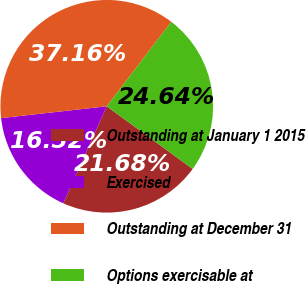<chart> <loc_0><loc_0><loc_500><loc_500><pie_chart><fcel>Outstanding at January 1 2015<fcel>Exercised<fcel>Outstanding at December 31<fcel>Options exercisable at<nl><fcel>21.68%<fcel>16.52%<fcel>37.16%<fcel>24.64%<nl></chart> 